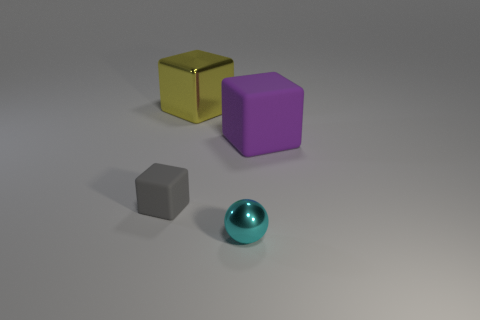Subtract all spheres. How many objects are left? 3 Subtract 1 blocks. How many blocks are left? 2 Subtract all purple spheres. Subtract all green cylinders. How many spheres are left? 1 Subtract all red spheres. How many purple cubes are left? 1 Subtract all green rubber balls. Subtract all metallic things. How many objects are left? 2 Add 2 small cyan shiny spheres. How many small cyan shiny spheres are left? 3 Add 2 tiny cyan metal spheres. How many tiny cyan metal spheres exist? 3 Add 3 yellow metal blocks. How many objects exist? 7 Subtract all large cubes. How many cubes are left? 1 Subtract 0 brown blocks. How many objects are left? 4 